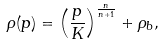<formula> <loc_0><loc_0><loc_500><loc_500>\rho ( p ) = \left ( \frac { p } { K } \right ) ^ { \frac { n } { n + 1 } } + \rho _ { b } ,</formula> 